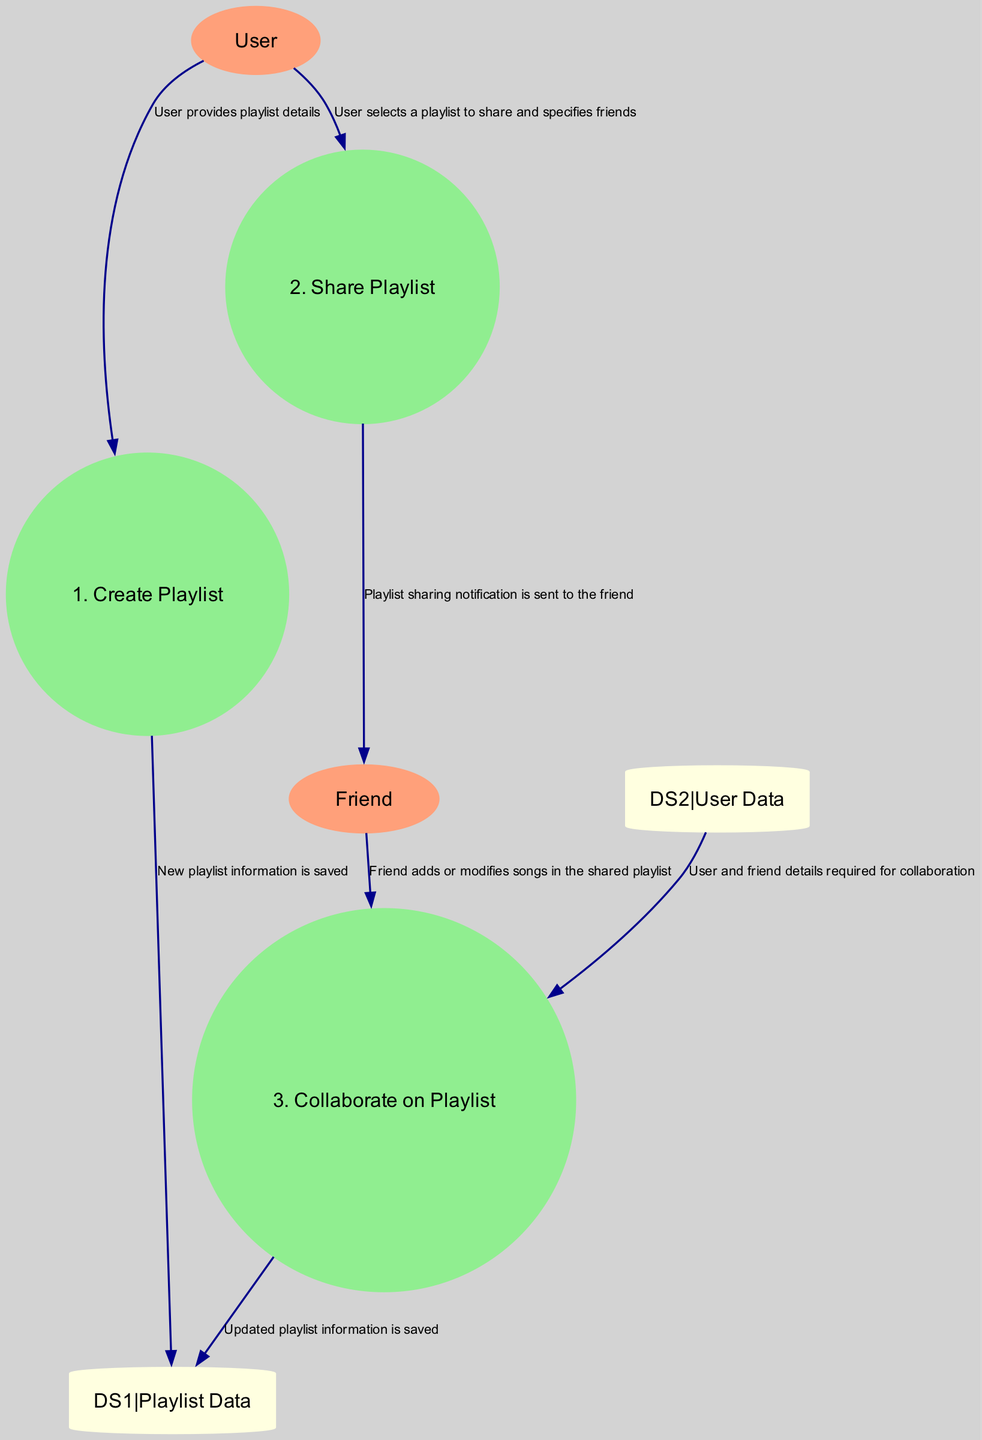What are the external entities in the diagram? The diagram includes two external entities: "User" and "Friend." The user is a casual music listener, while the friend is another user with whom the primary user shares playlists.
Answer: User, Friend How many processes are in the diagram? There are three processes shown in the diagram: "Create Playlist," "Share Playlist," and "Collaborate on Playlist."
Answer: 3 What does the "Create Playlist" process do? The "Create Playlist" process is where the user creates a new playlist on the streaming service. This is explicitly stated in the process description.
Answer: The user creates a new playlist Which data store contains user-created playlists? The data store labeled "Playlist Data" is specifically designated to keep user-created playlists, as stated in its description.
Answer: Playlist Data What is the purpose of the "Share Playlist" process? The "Share Playlist" process involves the user sharing the created playlist with friends. This function is crucial for collaborative playlist culture among users.
Answer: User shares the created playlist What data flows from "User" to "Share Playlist"? The data flow from "User" to "Share Playlist" is about the user selecting a playlist to share and specifying friends. This interaction is part of the overall sharing process.
Answer: User selects a playlist to share How does a friend contribute to the shared playlist? The friend contributes to the shared playlist by adding or modifying songs as indicated in the flow from "Friend" to "Collaborate on Playlist."
Answer: Friend adds or modifies songs What happens after collaboration on a playlist? After collaboration on a playlist, the updated playlist information is saved to "Playlist Data," ensuring any modifications are recorded as part of the playlist.
Answer: Updated playlist information is saved What do you need to collaborate on a playlist? To collaborate on a playlist, user and friend details are required, which are sourced from "User Data" as per the flow in the diagram.
Answer: User and friend details Which process sends a notification to the friend? The "Share Playlist" process sends a notification to the friend informing them about a shared playlist. This is part of the sharing interaction between the user and friend.
Answer: Share Playlist 